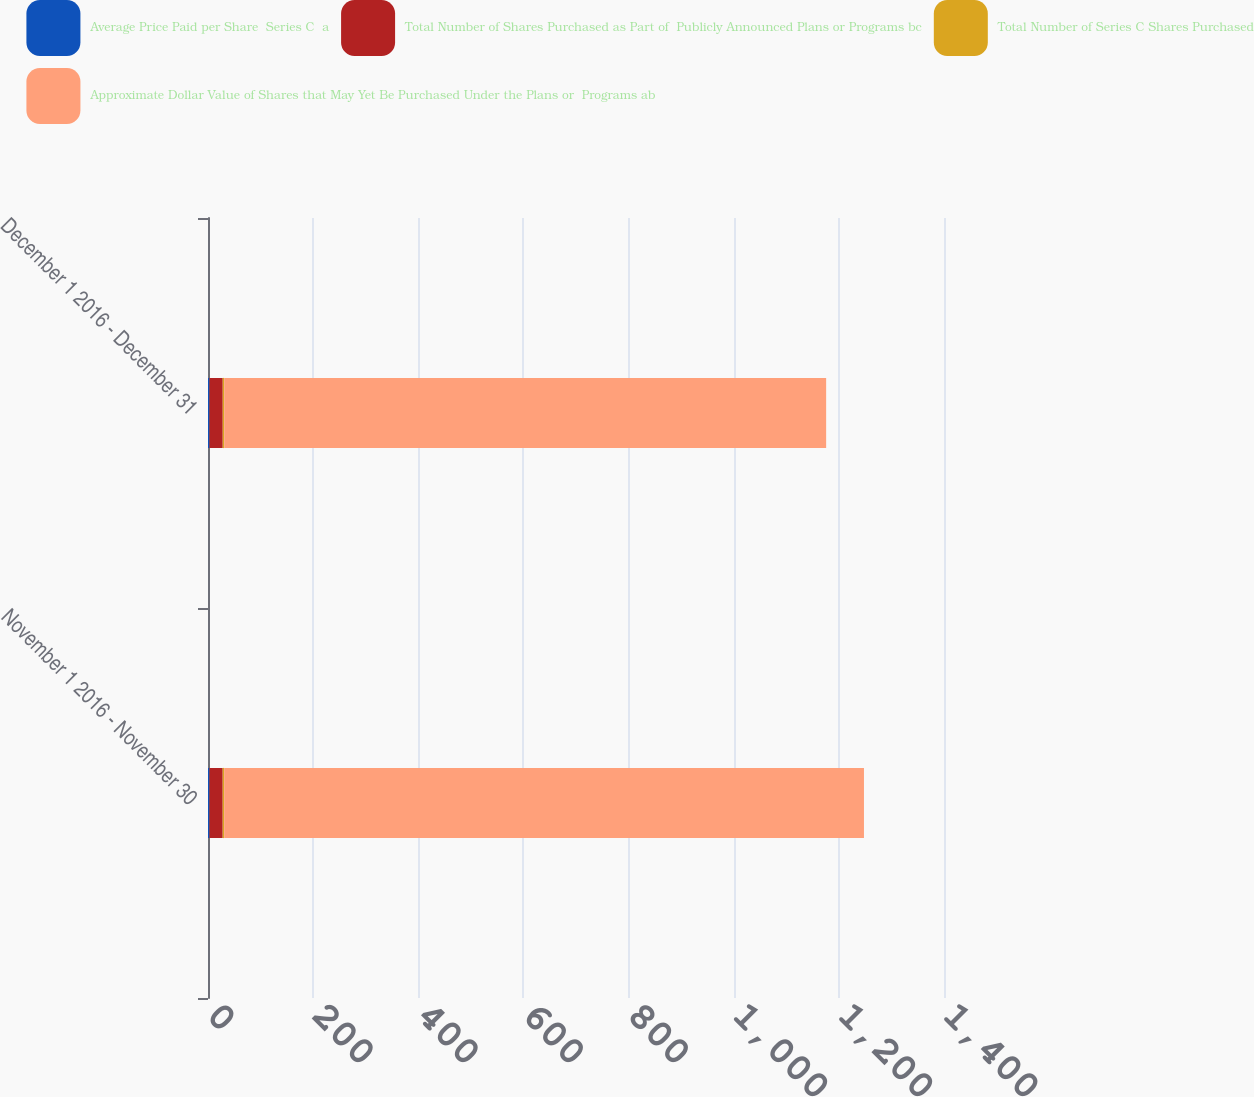Convert chart. <chart><loc_0><loc_0><loc_500><loc_500><stacked_bar_chart><ecel><fcel>November 1 2016 - November 30<fcel>December 1 2016 - December 31<nl><fcel>Average Price Paid per Share  Series C  a<fcel>2.8<fcel>2.8<nl><fcel>Total Number of Shares Purchased as Part of  Publicly Announced Plans or Programs bc<fcel>25.16<fcel>25.24<nl><fcel>Total Number of Series C Shares Purchased<fcel>2.8<fcel>2.8<nl><fcel>Approximate Dollar Value of Shares that May Yet Be Purchased Under the Plans or  Programs ab<fcel>1217<fcel>1145<nl></chart> 